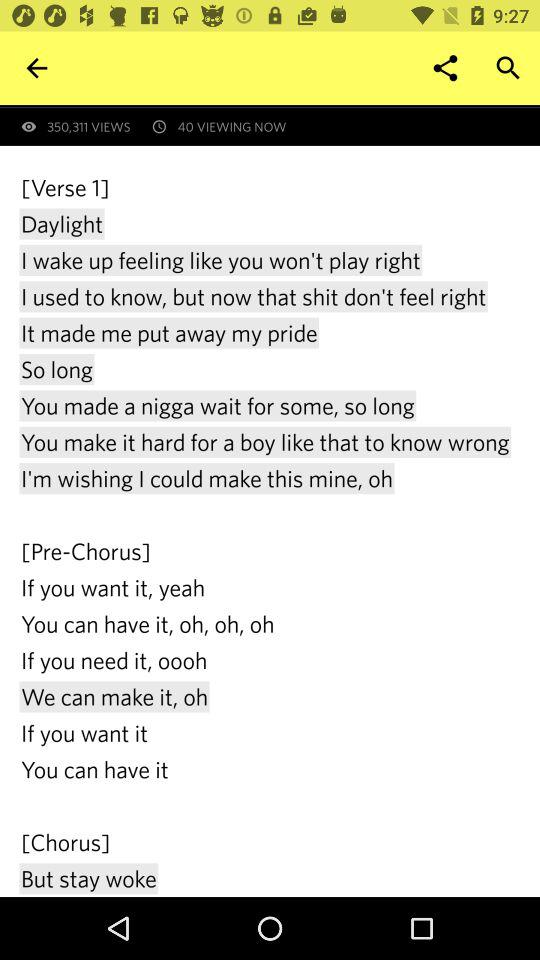How many people are viewing it now? There are 40 people who are viewing it now. 